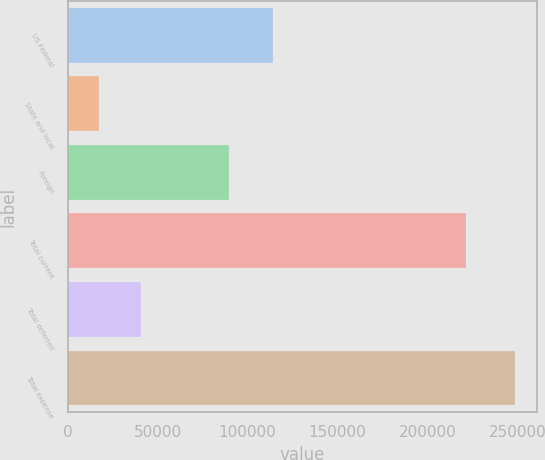<chart> <loc_0><loc_0><loc_500><loc_500><bar_chart><fcel>US Federal<fcel>State and local<fcel>Foreign<fcel>Total current<fcel>Total deferred<fcel>Total expense<nl><fcel>114218<fcel>17468<fcel>89702<fcel>221388<fcel>40567.1<fcel>248459<nl></chart> 